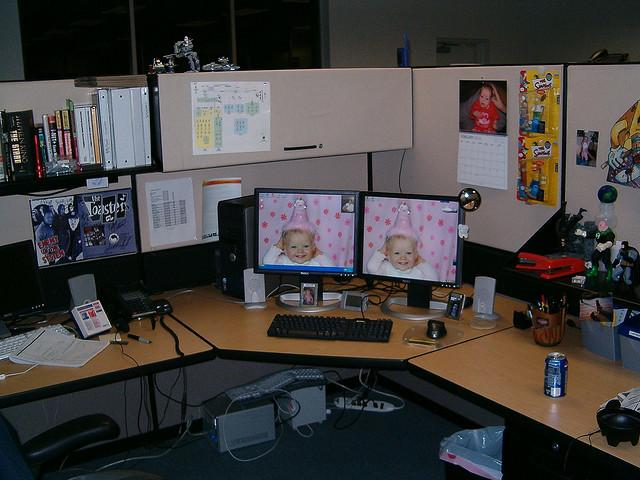Where is this desk setup?

Choices:
A) in hallway
B) on train
C) at work
D) in library at work 